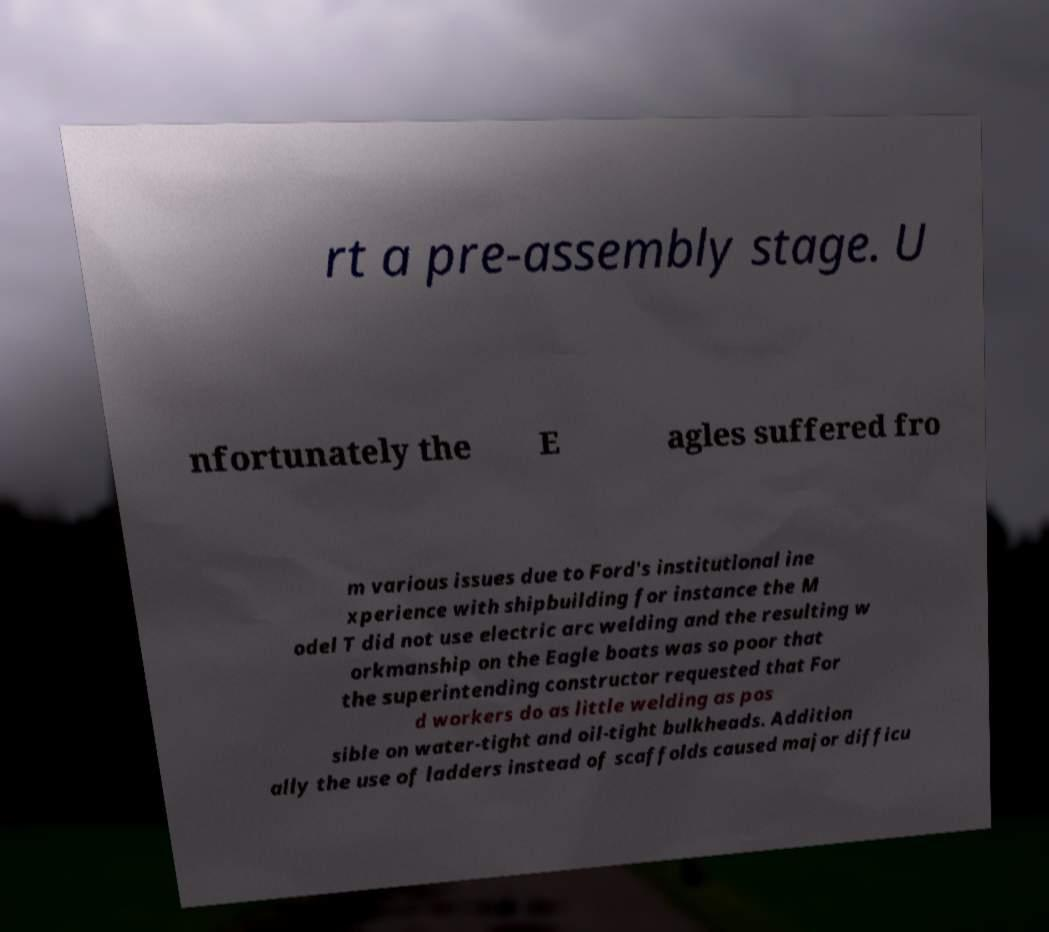Could you assist in decoding the text presented in this image and type it out clearly? rt a pre-assembly stage. U nfortunately the E agles suffered fro m various issues due to Ford's institutional ine xperience with shipbuilding for instance the M odel T did not use electric arc welding and the resulting w orkmanship on the Eagle boats was so poor that the superintending constructor requested that For d workers do as little welding as pos sible on water-tight and oil-tight bulkheads. Addition ally the use of ladders instead of scaffolds caused major difficu 